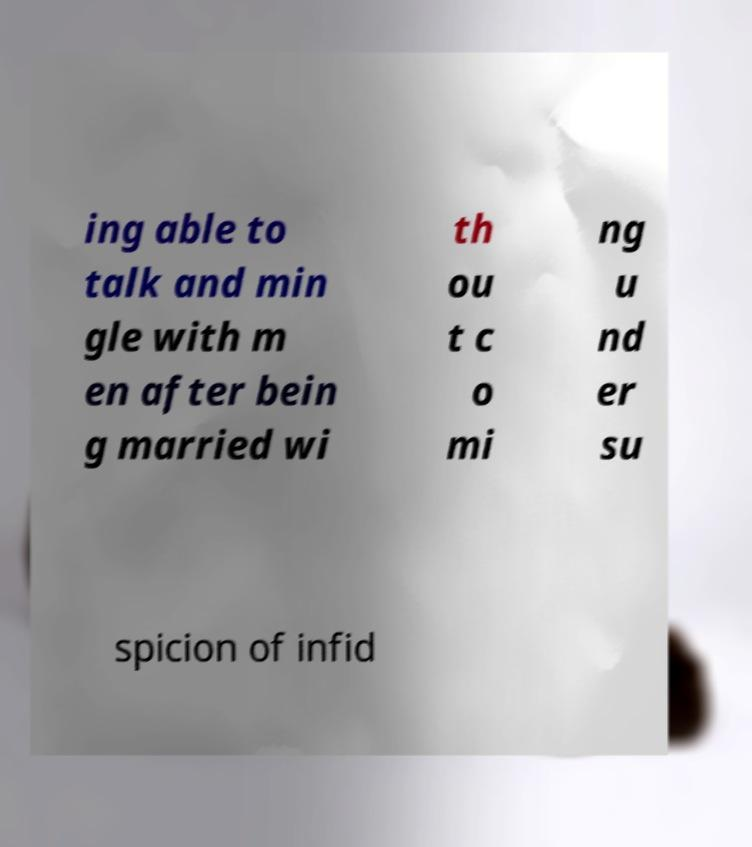Could you assist in decoding the text presented in this image and type it out clearly? ing able to talk and min gle with m en after bein g married wi th ou t c o mi ng u nd er su spicion of infid 